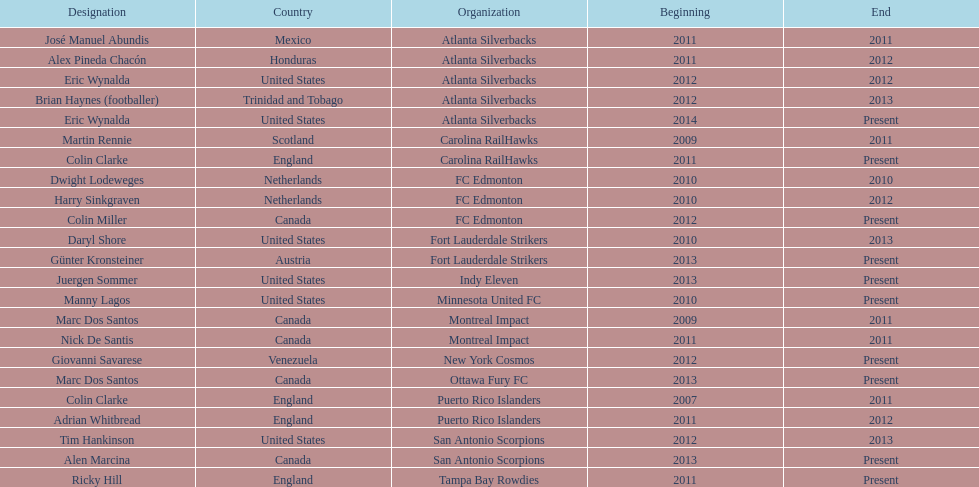How many coaches have coached from america? 6. 